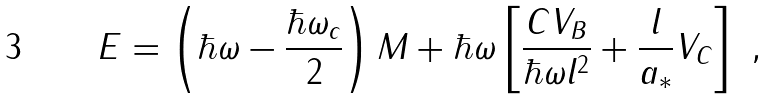<formula> <loc_0><loc_0><loc_500><loc_500>E = \left ( \hbar { \omega } - \frac { \hbar { \omega } _ { c } } { 2 } \right ) M + \hbar { \omega } \left [ \frac { C V _ { B } } { \hbar { \omega } l ^ { 2 } } + \frac { l } { a _ { * } } V _ { C } \right ] \ ,</formula> 